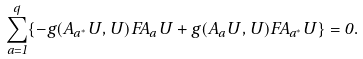Convert formula to latex. <formula><loc_0><loc_0><loc_500><loc_500>\sum _ { a = 1 } ^ { q } \{ - g ( A _ { a ^ { * } } U , U ) F A _ { a } U + g ( A _ { a } U , U ) F A _ { a ^ { * } } U \} = 0 .</formula> 